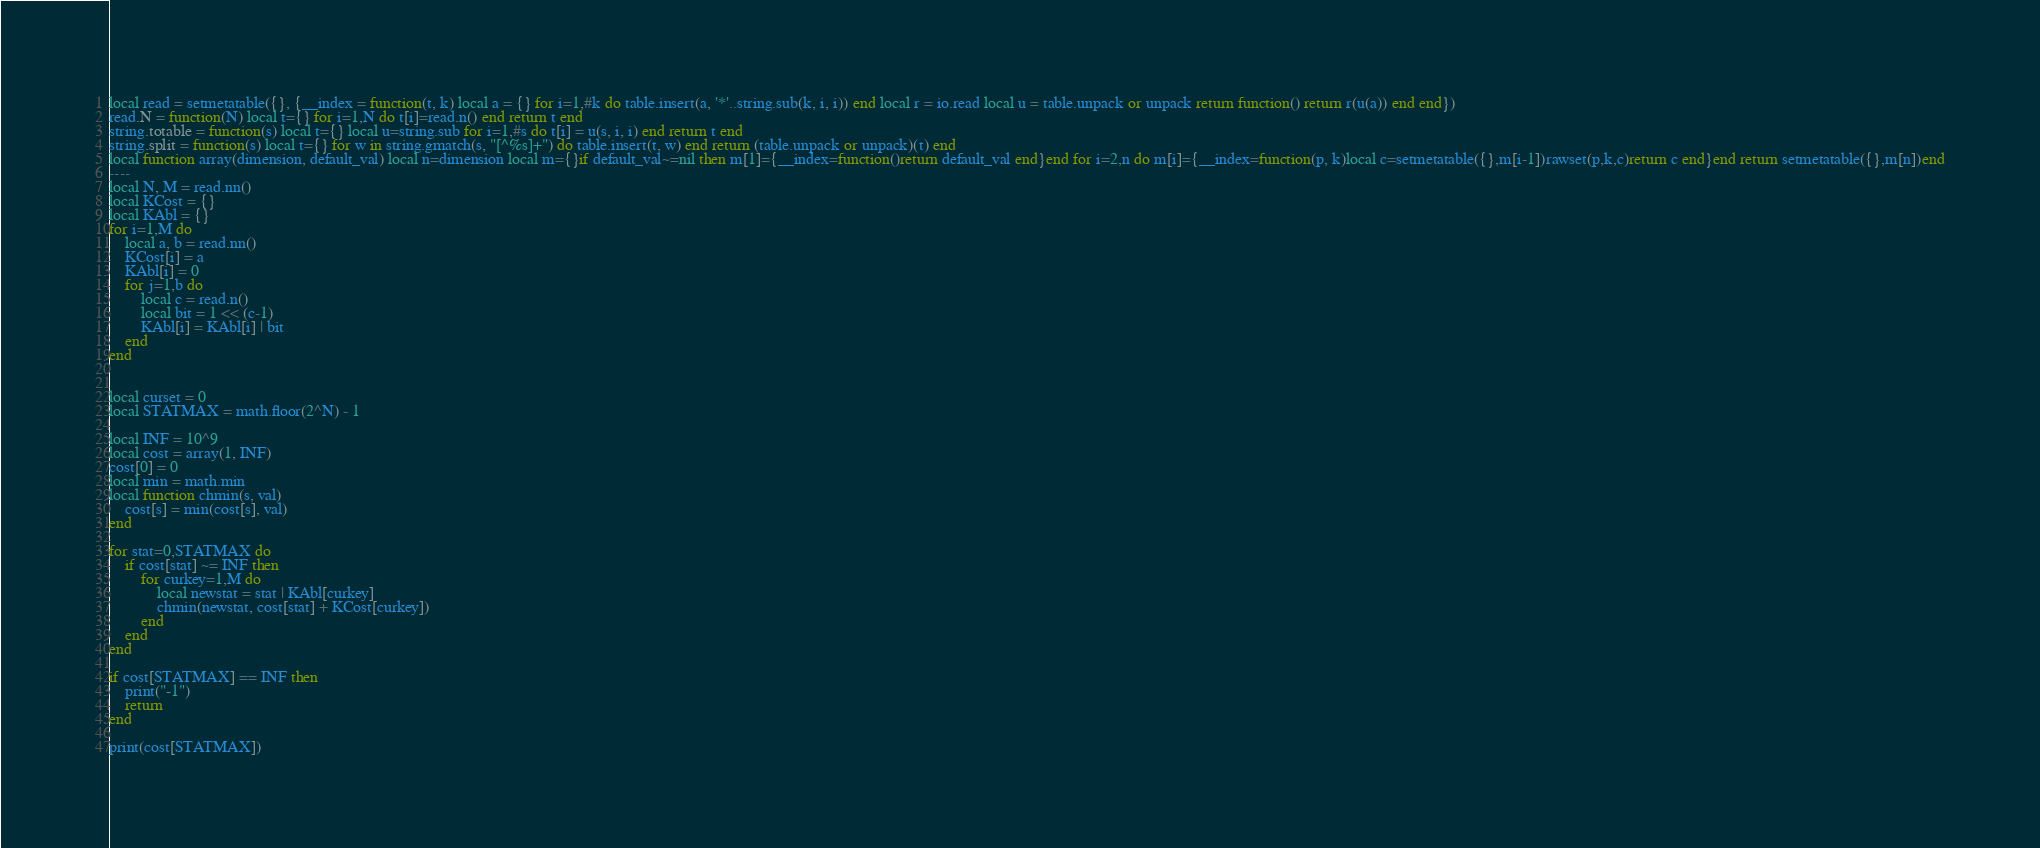Convert code to text. <code><loc_0><loc_0><loc_500><loc_500><_Lua_>local read = setmetatable({}, {__index = function(t, k) local a = {} for i=1,#k do table.insert(a, '*'..string.sub(k, i, i)) end local r = io.read local u = table.unpack or unpack return function() return r(u(a)) end end})
read.N = function(N) local t={} for i=1,N do t[i]=read.n() end return t end
string.totable = function(s) local t={} local u=string.sub for i=1,#s do t[i] = u(s, i, i) end return t end
string.split = function(s) local t={} for w in string.gmatch(s, "[^%s]+") do table.insert(t, w) end return (table.unpack or unpack)(t) end
local function array(dimension, default_val) local n=dimension local m={}if default_val~=nil then m[1]={__index=function()return default_val end}end for i=2,n do m[i]={__index=function(p, k)local c=setmetatable({},m[i-1])rawset(p,k,c)return c end}end return setmetatable({},m[n])end
----
local N, M = read.nn()
local KCost = {}
local KAbl = {}
for i=1,M do
    local a, b = read.nn()
    KCost[i] = a
    KAbl[i] = 0
    for j=1,b do
        local c = read.n()
        local bit = 1 << (c-1)
        KAbl[i] = KAbl[i] | bit
    end
end


local curset = 0
local STATMAX = math.floor(2^N) - 1

local INF = 10^9
local cost = array(1, INF)
cost[0] = 0
local min = math.min
local function chmin(s, val)
    cost[s] = min(cost[s], val)
end

for stat=0,STATMAX do
    if cost[stat] ~= INF then
        for curkey=1,M do
            local newstat = stat | KAbl[curkey]
            chmin(newstat, cost[stat] + KCost[curkey])
        end
    end
end

if cost[STATMAX] == INF then
    print("-1")
    return
end

print(cost[STATMAX])
</code> 